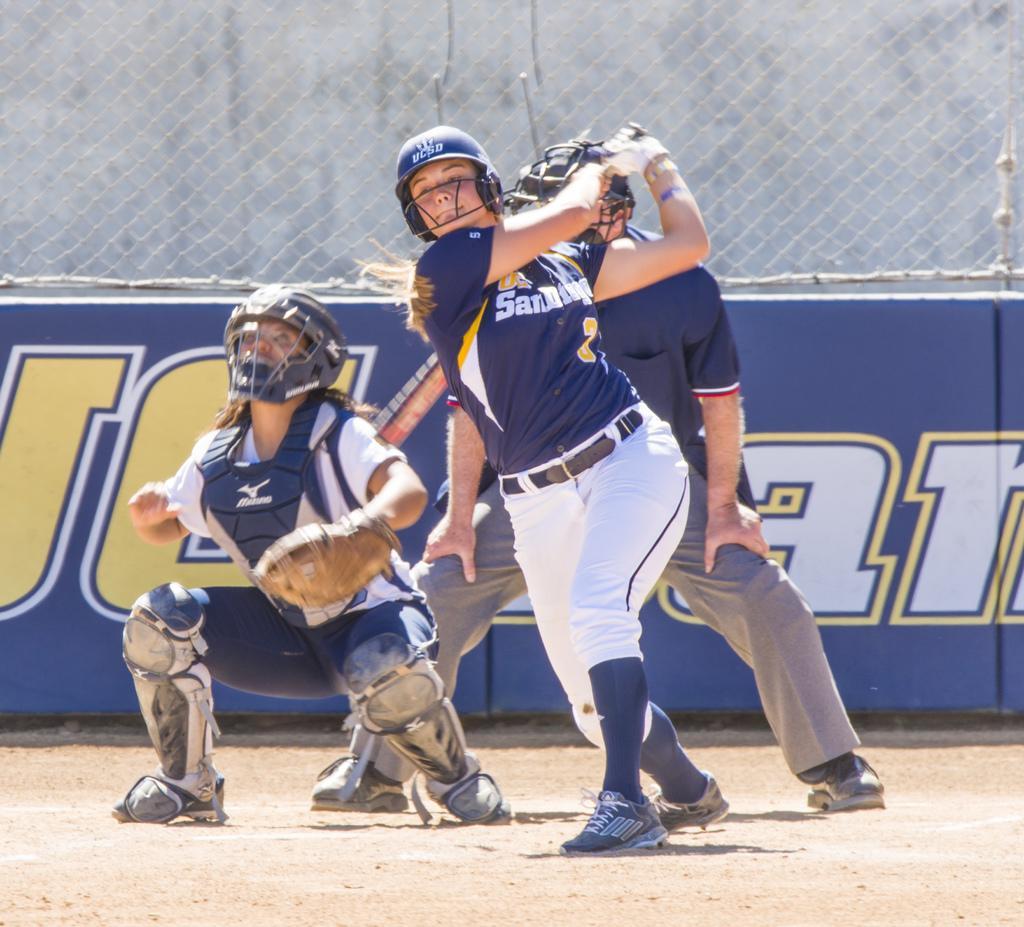Can you describe this image briefly? In this image, we can see a woman holding a stick and she is wearing a helmet, at the left side there is a woman in a squat position, she is also wearing a helmet, there is a referee standing, in the background there is a blue color poster and there is a fence. 